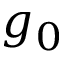<formula> <loc_0><loc_0><loc_500><loc_500>g _ { 0 }</formula> 